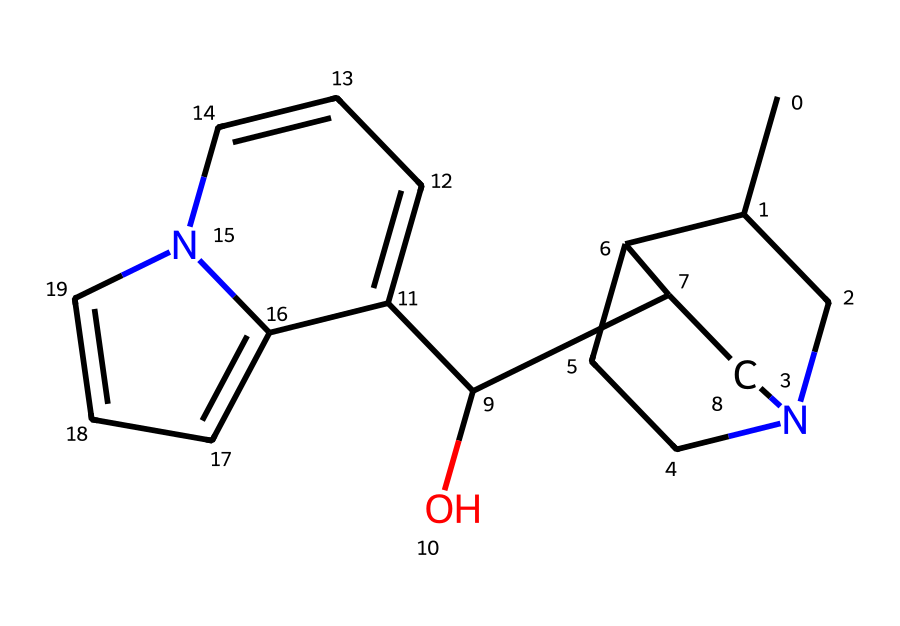What is the molecular formula of quinine? By analyzing the structure derived from the SMILES notation, count the number of carbon (C), hydrogen (H), nitrogen (N), and oxygen (O) atoms. The formula can be derived from the number of each type of atom present in the compound.
Answer: C20H24N2O2 How many rings are present in the structure of quinine? Examine the structure to identify distinct ring formations. By looking at the connectivity of the atoms in the provided SMILES, we can count the individual cyclic structures. There are two clear ring systems in quinine.
Answer: 2 Which element in the structure is responsible for the therapeutic effects against malaria? The nitrogen atoms in the structure are characteristic of many alkaloids, including quinine, that possess pharmacological activity, particularly against malaria. They play a vital role in binding to biological targets in the body.
Answer: nitrogen What type of chemical compound is quinine classified as? Quinine has a complex structure with nitrogen atoms and is primarily derived from plants, indicating that it is an alkaloid. Alkaloids are known for their pharmacological properties and include substances like quinine that are used for treatment.
Answer: alkaloid What specific functional group is present in the quinine structure? By analyzing the chemical structure, identify the presence of a hydroxyl (–OH) group, which is indicative of alcohols and can influence both solubility and reactivity of the compound.
Answer: hydroxyl What is the role of the oxygen atoms in the quinine molecule? The oxygen atoms contribute to the hydrogen bonding capability of the molecule, assisting in interactions with biological systems. They play an essential role in the solubility and stability of quinine as a drug.
Answer: hydrogen bonding 